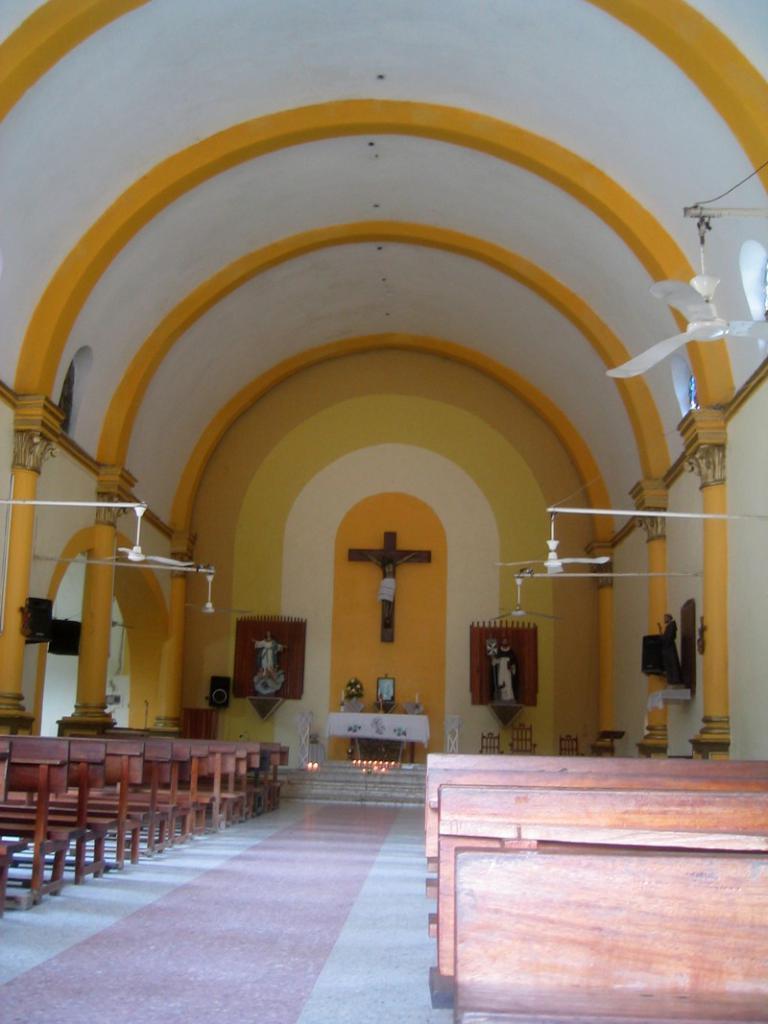Can you describe this image briefly? This is inside of the building, we can see benches, fans, poles and speakers. In the background we can see statues, candles, steps, objects on the table, chairs, cross symbol and wall. 